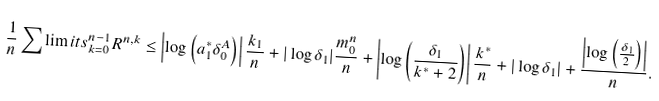Convert formula to latex. <formula><loc_0><loc_0><loc_500><loc_500>\frac { 1 } { n } \sum \lim i t s _ { k = 0 } ^ { n - 1 } R ^ { n , k } \leq \left | \log \left ( a _ { 1 } ^ { * } \delta _ { 0 } ^ { A } \right ) \right | \frac { k _ { 1 } } { n } + | \log \delta _ { 1 } | \frac { m ^ { n } _ { 0 } } { n } + \left | \log \left ( \frac { \delta _ { 1 } } { k ^ { * } + 2 } \right ) \right | \frac { k ^ { * } } { n } + | \log \delta _ { 1 } | + \frac { \left | \log \left ( \frac { \delta _ { 1 } } { 2 } \right ) \right | } { n } .</formula> 